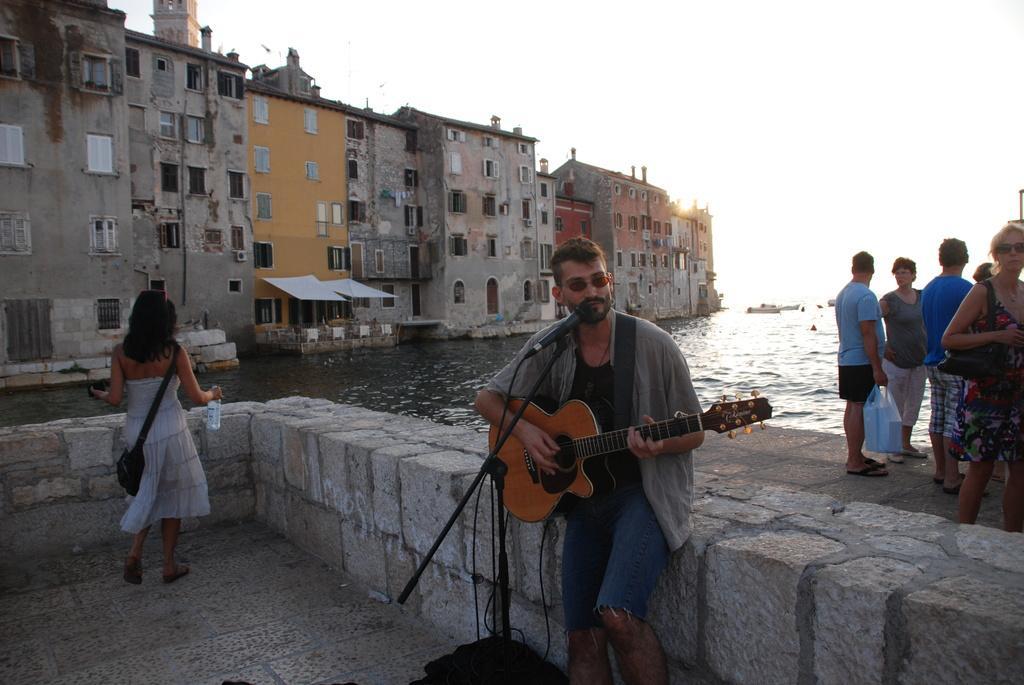Can you describe this image briefly? This is a picture of a man in black t shirt holding a guitar and singing a song in front of the man there are microphone with stand. Background of the man there are buildings, water and group of people and sky. 